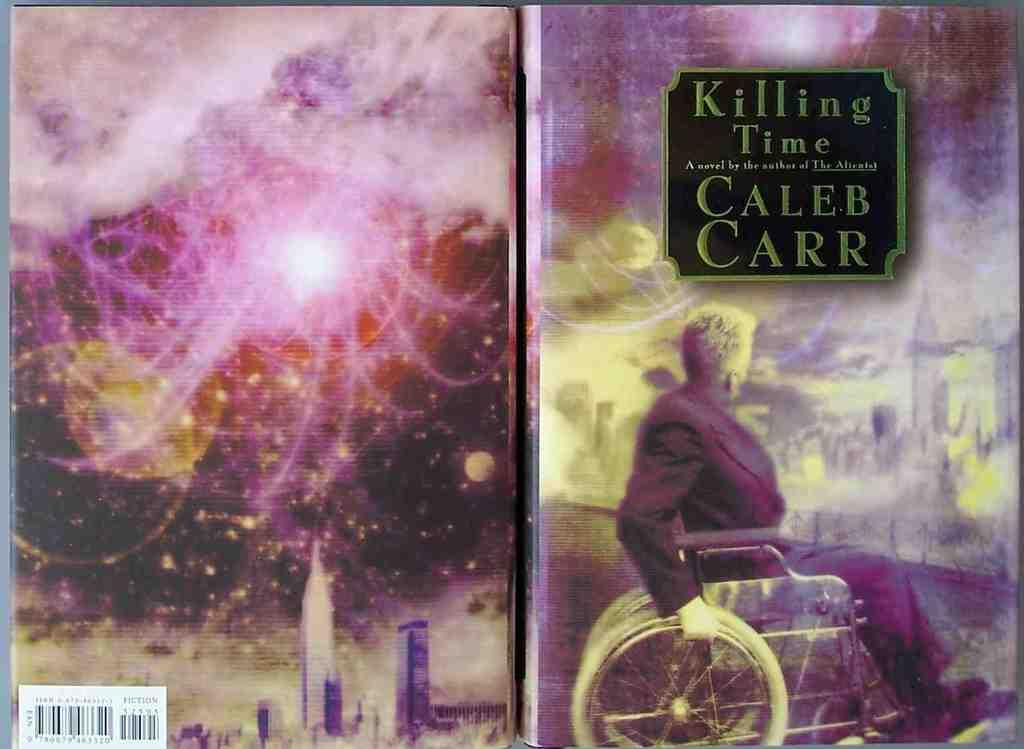<image>
Write a terse but informative summary of the picture. The book Killing Time was written by Caleb Carr. 